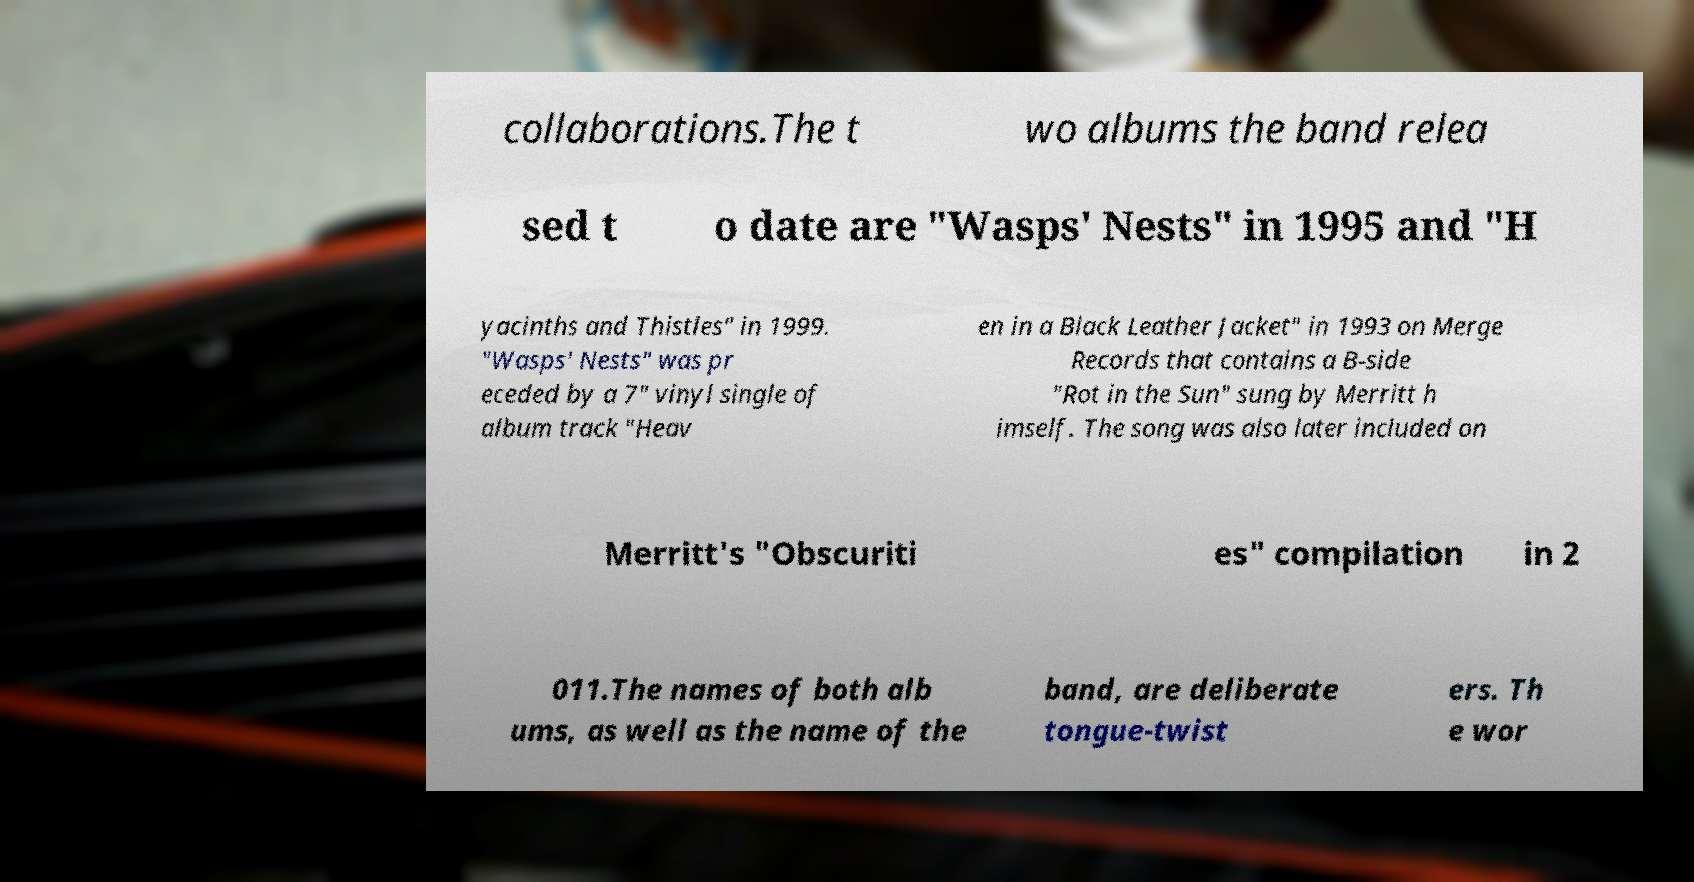For documentation purposes, I need the text within this image transcribed. Could you provide that? collaborations.The t wo albums the band relea sed t o date are "Wasps' Nests" in 1995 and "H yacinths and Thistles" in 1999. "Wasps' Nests" was pr eceded by a 7" vinyl single of album track "Heav en in a Black Leather Jacket" in 1993 on Merge Records that contains a B-side "Rot in the Sun" sung by Merritt h imself. The song was also later included on Merritt's "Obscuriti es" compilation in 2 011.The names of both alb ums, as well as the name of the band, are deliberate tongue-twist ers. Th e wor 